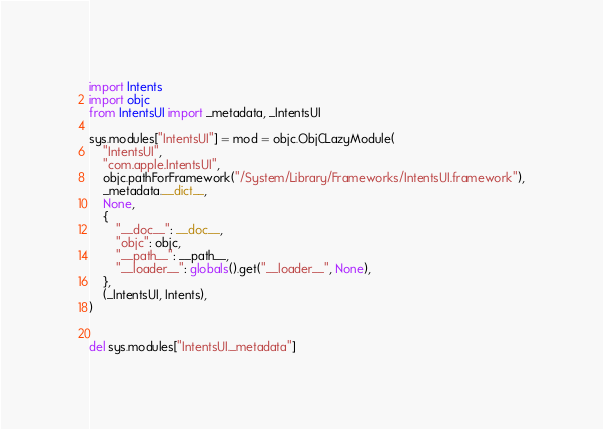<code> <loc_0><loc_0><loc_500><loc_500><_Python_>
import Intents
import objc
from IntentsUI import _metadata, _IntentsUI

sys.modules["IntentsUI"] = mod = objc.ObjCLazyModule(
    "IntentsUI",
    "com.apple.IntentsUI",
    objc.pathForFramework("/System/Library/Frameworks/IntentsUI.framework"),
    _metadata.__dict__,
    None,
    {
        "__doc__": __doc__,
        "objc": objc,
        "__path__": __path__,
        "__loader__": globals().get("__loader__", None),
    },
    (_IntentsUI, Intents),
)


del sys.modules["IntentsUI._metadata"]
</code> 